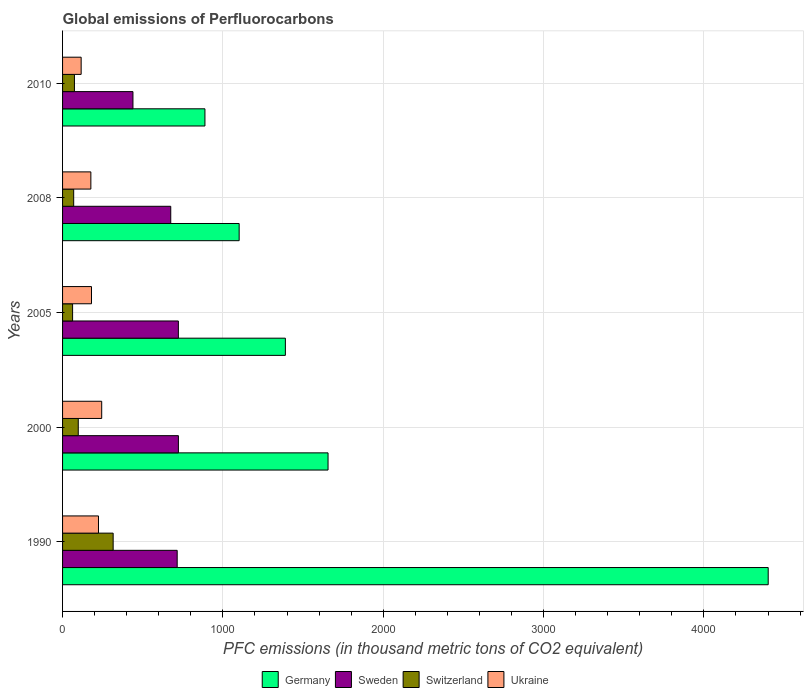How many different coloured bars are there?
Your response must be concise. 4. How many groups of bars are there?
Ensure brevity in your answer.  5. Are the number of bars per tick equal to the number of legend labels?
Your response must be concise. Yes. Are the number of bars on each tick of the Y-axis equal?
Give a very brief answer. Yes. How many bars are there on the 3rd tick from the bottom?
Your response must be concise. 4. What is the label of the 5th group of bars from the top?
Provide a short and direct response. 1990. In how many cases, is the number of bars for a given year not equal to the number of legend labels?
Give a very brief answer. 0. What is the global emissions of Perfluorocarbons in Switzerland in 2005?
Keep it short and to the point. 62.5. Across all years, what is the maximum global emissions of Perfluorocarbons in Germany?
Ensure brevity in your answer.  4401.3. Across all years, what is the minimum global emissions of Perfluorocarbons in Germany?
Make the answer very short. 888. In which year was the global emissions of Perfluorocarbons in Switzerland maximum?
Offer a terse response. 1990. What is the total global emissions of Perfluorocarbons in Ukraine in the graph?
Offer a terse response. 941.1. What is the difference between the global emissions of Perfluorocarbons in Ukraine in 1990 and that in 2008?
Your answer should be compact. 47.5. What is the difference between the global emissions of Perfluorocarbons in Germany in 2000 and the global emissions of Perfluorocarbons in Switzerland in 2008?
Give a very brief answer. 1586.5. What is the average global emissions of Perfluorocarbons in Switzerland per year?
Make the answer very short. 123.86. In the year 2005, what is the difference between the global emissions of Perfluorocarbons in Ukraine and global emissions of Perfluorocarbons in Germany?
Offer a terse response. -1209.2. In how many years, is the global emissions of Perfluorocarbons in Switzerland greater than 4400 thousand metric tons?
Offer a terse response. 0. What is the ratio of the global emissions of Perfluorocarbons in Sweden in 2000 to that in 2010?
Offer a very short reply. 1.65. Is the global emissions of Perfluorocarbons in Germany in 1990 less than that in 2008?
Provide a short and direct response. No. What is the difference between the highest and the second highest global emissions of Perfluorocarbons in Sweden?
Your answer should be very brief. 0.2. What is the difference between the highest and the lowest global emissions of Perfluorocarbons in Germany?
Offer a very short reply. 3513.3. In how many years, is the global emissions of Perfluorocarbons in Germany greater than the average global emissions of Perfluorocarbons in Germany taken over all years?
Your answer should be compact. 1. Is it the case that in every year, the sum of the global emissions of Perfluorocarbons in Switzerland and global emissions of Perfluorocarbons in Germany is greater than the sum of global emissions of Perfluorocarbons in Sweden and global emissions of Perfluorocarbons in Ukraine?
Give a very brief answer. No. What does the 3rd bar from the bottom in 2005 represents?
Your answer should be compact. Switzerland. Is it the case that in every year, the sum of the global emissions of Perfluorocarbons in Ukraine and global emissions of Perfluorocarbons in Switzerland is greater than the global emissions of Perfluorocarbons in Sweden?
Your response must be concise. No. Are the values on the major ticks of X-axis written in scientific E-notation?
Provide a succinct answer. No. Does the graph contain any zero values?
Provide a succinct answer. No. How many legend labels are there?
Your answer should be very brief. 4. How are the legend labels stacked?
Your response must be concise. Horizontal. What is the title of the graph?
Provide a short and direct response. Global emissions of Perfluorocarbons. Does "Albania" appear as one of the legend labels in the graph?
Your answer should be compact. No. What is the label or title of the X-axis?
Your response must be concise. PFC emissions (in thousand metric tons of CO2 equivalent). What is the PFC emissions (in thousand metric tons of CO2 equivalent) in Germany in 1990?
Make the answer very short. 4401.3. What is the PFC emissions (in thousand metric tons of CO2 equivalent) of Sweden in 1990?
Your answer should be very brief. 714.9. What is the PFC emissions (in thousand metric tons of CO2 equivalent) in Switzerland in 1990?
Offer a very short reply. 315.5. What is the PFC emissions (in thousand metric tons of CO2 equivalent) of Ukraine in 1990?
Your answer should be compact. 224. What is the PFC emissions (in thousand metric tons of CO2 equivalent) in Germany in 2000?
Ensure brevity in your answer.  1655.9. What is the PFC emissions (in thousand metric tons of CO2 equivalent) in Sweden in 2000?
Provide a succinct answer. 722.5. What is the PFC emissions (in thousand metric tons of CO2 equivalent) in Switzerland in 2000?
Make the answer very short. 97.9. What is the PFC emissions (in thousand metric tons of CO2 equivalent) of Ukraine in 2000?
Give a very brief answer. 244.1. What is the PFC emissions (in thousand metric tons of CO2 equivalent) in Germany in 2005?
Provide a succinct answer. 1389.7. What is the PFC emissions (in thousand metric tons of CO2 equivalent) in Sweden in 2005?
Your answer should be compact. 722.3. What is the PFC emissions (in thousand metric tons of CO2 equivalent) in Switzerland in 2005?
Ensure brevity in your answer.  62.5. What is the PFC emissions (in thousand metric tons of CO2 equivalent) of Ukraine in 2005?
Offer a very short reply. 180.5. What is the PFC emissions (in thousand metric tons of CO2 equivalent) in Germany in 2008?
Make the answer very short. 1101.4. What is the PFC emissions (in thousand metric tons of CO2 equivalent) of Sweden in 2008?
Make the answer very short. 674.8. What is the PFC emissions (in thousand metric tons of CO2 equivalent) of Switzerland in 2008?
Your answer should be compact. 69.4. What is the PFC emissions (in thousand metric tons of CO2 equivalent) in Ukraine in 2008?
Offer a very short reply. 176.5. What is the PFC emissions (in thousand metric tons of CO2 equivalent) of Germany in 2010?
Ensure brevity in your answer.  888. What is the PFC emissions (in thousand metric tons of CO2 equivalent) of Sweden in 2010?
Make the answer very short. 439. What is the PFC emissions (in thousand metric tons of CO2 equivalent) of Switzerland in 2010?
Give a very brief answer. 74. What is the PFC emissions (in thousand metric tons of CO2 equivalent) of Ukraine in 2010?
Your response must be concise. 116. Across all years, what is the maximum PFC emissions (in thousand metric tons of CO2 equivalent) in Germany?
Give a very brief answer. 4401.3. Across all years, what is the maximum PFC emissions (in thousand metric tons of CO2 equivalent) in Sweden?
Provide a short and direct response. 722.5. Across all years, what is the maximum PFC emissions (in thousand metric tons of CO2 equivalent) of Switzerland?
Keep it short and to the point. 315.5. Across all years, what is the maximum PFC emissions (in thousand metric tons of CO2 equivalent) in Ukraine?
Ensure brevity in your answer.  244.1. Across all years, what is the minimum PFC emissions (in thousand metric tons of CO2 equivalent) in Germany?
Give a very brief answer. 888. Across all years, what is the minimum PFC emissions (in thousand metric tons of CO2 equivalent) in Sweden?
Ensure brevity in your answer.  439. Across all years, what is the minimum PFC emissions (in thousand metric tons of CO2 equivalent) of Switzerland?
Your answer should be compact. 62.5. Across all years, what is the minimum PFC emissions (in thousand metric tons of CO2 equivalent) in Ukraine?
Your answer should be compact. 116. What is the total PFC emissions (in thousand metric tons of CO2 equivalent) in Germany in the graph?
Offer a very short reply. 9436.3. What is the total PFC emissions (in thousand metric tons of CO2 equivalent) in Sweden in the graph?
Your answer should be very brief. 3273.5. What is the total PFC emissions (in thousand metric tons of CO2 equivalent) in Switzerland in the graph?
Ensure brevity in your answer.  619.3. What is the total PFC emissions (in thousand metric tons of CO2 equivalent) in Ukraine in the graph?
Provide a succinct answer. 941.1. What is the difference between the PFC emissions (in thousand metric tons of CO2 equivalent) of Germany in 1990 and that in 2000?
Offer a terse response. 2745.4. What is the difference between the PFC emissions (in thousand metric tons of CO2 equivalent) of Switzerland in 1990 and that in 2000?
Keep it short and to the point. 217.6. What is the difference between the PFC emissions (in thousand metric tons of CO2 equivalent) of Ukraine in 1990 and that in 2000?
Offer a terse response. -20.1. What is the difference between the PFC emissions (in thousand metric tons of CO2 equivalent) in Germany in 1990 and that in 2005?
Provide a succinct answer. 3011.6. What is the difference between the PFC emissions (in thousand metric tons of CO2 equivalent) in Switzerland in 1990 and that in 2005?
Make the answer very short. 253. What is the difference between the PFC emissions (in thousand metric tons of CO2 equivalent) in Ukraine in 1990 and that in 2005?
Provide a succinct answer. 43.5. What is the difference between the PFC emissions (in thousand metric tons of CO2 equivalent) in Germany in 1990 and that in 2008?
Your answer should be compact. 3299.9. What is the difference between the PFC emissions (in thousand metric tons of CO2 equivalent) in Sweden in 1990 and that in 2008?
Provide a succinct answer. 40.1. What is the difference between the PFC emissions (in thousand metric tons of CO2 equivalent) of Switzerland in 1990 and that in 2008?
Provide a short and direct response. 246.1. What is the difference between the PFC emissions (in thousand metric tons of CO2 equivalent) of Ukraine in 1990 and that in 2008?
Your answer should be compact. 47.5. What is the difference between the PFC emissions (in thousand metric tons of CO2 equivalent) in Germany in 1990 and that in 2010?
Provide a short and direct response. 3513.3. What is the difference between the PFC emissions (in thousand metric tons of CO2 equivalent) in Sweden in 1990 and that in 2010?
Your answer should be compact. 275.9. What is the difference between the PFC emissions (in thousand metric tons of CO2 equivalent) in Switzerland in 1990 and that in 2010?
Give a very brief answer. 241.5. What is the difference between the PFC emissions (in thousand metric tons of CO2 equivalent) of Ukraine in 1990 and that in 2010?
Your answer should be compact. 108. What is the difference between the PFC emissions (in thousand metric tons of CO2 equivalent) of Germany in 2000 and that in 2005?
Keep it short and to the point. 266.2. What is the difference between the PFC emissions (in thousand metric tons of CO2 equivalent) in Switzerland in 2000 and that in 2005?
Your answer should be compact. 35.4. What is the difference between the PFC emissions (in thousand metric tons of CO2 equivalent) in Ukraine in 2000 and that in 2005?
Provide a succinct answer. 63.6. What is the difference between the PFC emissions (in thousand metric tons of CO2 equivalent) in Germany in 2000 and that in 2008?
Give a very brief answer. 554.5. What is the difference between the PFC emissions (in thousand metric tons of CO2 equivalent) of Sweden in 2000 and that in 2008?
Provide a short and direct response. 47.7. What is the difference between the PFC emissions (in thousand metric tons of CO2 equivalent) of Switzerland in 2000 and that in 2008?
Keep it short and to the point. 28.5. What is the difference between the PFC emissions (in thousand metric tons of CO2 equivalent) in Ukraine in 2000 and that in 2008?
Offer a terse response. 67.6. What is the difference between the PFC emissions (in thousand metric tons of CO2 equivalent) in Germany in 2000 and that in 2010?
Keep it short and to the point. 767.9. What is the difference between the PFC emissions (in thousand metric tons of CO2 equivalent) of Sweden in 2000 and that in 2010?
Offer a very short reply. 283.5. What is the difference between the PFC emissions (in thousand metric tons of CO2 equivalent) in Switzerland in 2000 and that in 2010?
Your answer should be compact. 23.9. What is the difference between the PFC emissions (in thousand metric tons of CO2 equivalent) of Ukraine in 2000 and that in 2010?
Your answer should be compact. 128.1. What is the difference between the PFC emissions (in thousand metric tons of CO2 equivalent) in Germany in 2005 and that in 2008?
Give a very brief answer. 288.3. What is the difference between the PFC emissions (in thousand metric tons of CO2 equivalent) of Sweden in 2005 and that in 2008?
Provide a succinct answer. 47.5. What is the difference between the PFC emissions (in thousand metric tons of CO2 equivalent) of Switzerland in 2005 and that in 2008?
Give a very brief answer. -6.9. What is the difference between the PFC emissions (in thousand metric tons of CO2 equivalent) of Ukraine in 2005 and that in 2008?
Offer a terse response. 4. What is the difference between the PFC emissions (in thousand metric tons of CO2 equivalent) in Germany in 2005 and that in 2010?
Ensure brevity in your answer.  501.7. What is the difference between the PFC emissions (in thousand metric tons of CO2 equivalent) of Sweden in 2005 and that in 2010?
Offer a terse response. 283.3. What is the difference between the PFC emissions (in thousand metric tons of CO2 equivalent) in Switzerland in 2005 and that in 2010?
Keep it short and to the point. -11.5. What is the difference between the PFC emissions (in thousand metric tons of CO2 equivalent) in Ukraine in 2005 and that in 2010?
Your response must be concise. 64.5. What is the difference between the PFC emissions (in thousand metric tons of CO2 equivalent) in Germany in 2008 and that in 2010?
Make the answer very short. 213.4. What is the difference between the PFC emissions (in thousand metric tons of CO2 equivalent) in Sweden in 2008 and that in 2010?
Offer a very short reply. 235.8. What is the difference between the PFC emissions (in thousand metric tons of CO2 equivalent) in Switzerland in 2008 and that in 2010?
Your answer should be compact. -4.6. What is the difference between the PFC emissions (in thousand metric tons of CO2 equivalent) in Ukraine in 2008 and that in 2010?
Offer a very short reply. 60.5. What is the difference between the PFC emissions (in thousand metric tons of CO2 equivalent) of Germany in 1990 and the PFC emissions (in thousand metric tons of CO2 equivalent) of Sweden in 2000?
Offer a terse response. 3678.8. What is the difference between the PFC emissions (in thousand metric tons of CO2 equivalent) in Germany in 1990 and the PFC emissions (in thousand metric tons of CO2 equivalent) in Switzerland in 2000?
Give a very brief answer. 4303.4. What is the difference between the PFC emissions (in thousand metric tons of CO2 equivalent) of Germany in 1990 and the PFC emissions (in thousand metric tons of CO2 equivalent) of Ukraine in 2000?
Your response must be concise. 4157.2. What is the difference between the PFC emissions (in thousand metric tons of CO2 equivalent) in Sweden in 1990 and the PFC emissions (in thousand metric tons of CO2 equivalent) in Switzerland in 2000?
Provide a succinct answer. 617. What is the difference between the PFC emissions (in thousand metric tons of CO2 equivalent) of Sweden in 1990 and the PFC emissions (in thousand metric tons of CO2 equivalent) of Ukraine in 2000?
Keep it short and to the point. 470.8. What is the difference between the PFC emissions (in thousand metric tons of CO2 equivalent) of Switzerland in 1990 and the PFC emissions (in thousand metric tons of CO2 equivalent) of Ukraine in 2000?
Your answer should be compact. 71.4. What is the difference between the PFC emissions (in thousand metric tons of CO2 equivalent) in Germany in 1990 and the PFC emissions (in thousand metric tons of CO2 equivalent) in Sweden in 2005?
Provide a succinct answer. 3679. What is the difference between the PFC emissions (in thousand metric tons of CO2 equivalent) of Germany in 1990 and the PFC emissions (in thousand metric tons of CO2 equivalent) of Switzerland in 2005?
Provide a short and direct response. 4338.8. What is the difference between the PFC emissions (in thousand metric tons of CO2 equivalent) in Germany in 1990 and the PFC emissions (in thousand metric tons of CO2 equivalent) in Ukraine in 2005?
Make the answer very short. 4220.8. What is the difference between the PFC emissions (in thousand metric tons of CO2 equivalent) in Sweden in 1990 and the PFC emissions (in thousand metric tons of CO2 equivalent) in Switzerland in 2005?
Your response must be concise. 652.4. What is the difference between the PFC emissions (in thousand metric tons of CO2 equivalent) of Sweden in 1990 and the PFC emissions (in thousand metric tons of CO2 equivalent) of Ukraine in 2005?
Your response must be concise. 534.4. What is the difference between the PFC emissions (in thousand metric tons of CO2 equivalent) of Switzerland in 1990 and the PFC emissions (in thousand metric tons of CO2 equivalent) of Ukraine in 2005?
Make the answer very short. 135. What is the difference between the PFC emissions (in thousand metric tons of CO2 equivalent) of Germany in 1990 and the PFC emissions (in thousand metric tons of CO2 equivalent) of Sweden in 2008?
Keep it short and to the point. 3726.5. What is the difference between the PFC emissions (in thousand metric tons of CO2 equivalent) in Germany in 1990 and the PFC emissions (in thousand metric tons of CO2 equivalent) in Switzerland in 2008?
Your answer should be very brief. 4331.9. What is the difference between the PFC emissions (in thousand metric tons of CO2 equivalent) of Germany in 1990 and the PFC emissions (in thousand metric tons of CO2 equivalent) of Ukraine in 2008?
Your answer should be very brief. 4224.8. What is the difference between the PFC emissions (in thousand metric tons of CO2 equivalent) of Sweden in 1990 and the PFC emissions (in thousand metric tons of CO2 equivalent) of Switzerland in 2008?
Provide a short and direct response. 645.5. What is the difference between the PFC emissions (in thousand metric tons of CO2 equivalent) in Sweden in 1990 and the PFC emissions (in thousand metric tons of CO2 equivalent) in Ukraine in 2008?
Make the answer very short. 538.4. What is the difference between the PFC emissions (in thousand metric tons of CO2 equivalent) of Switzerland in 1990 and the PFC emissions (in thousand metric tons of CO2 equivalent) of Ukraine in 2008?
Provide a short and direct response. 139. What is the difference between the PFC emissions (in thousand metric tons of CO2 equivalent) of Germany in 1990 and the PFC emissions (in thousand metric tons of CO2 equivalent) of Sweden in 2010?
Provide a short and direct response. 3962.3. What is the difference between the PFC emissions (in thousand metric tons of CO2 equivalent) in Germany in 1990 and the PFC emissions (in thousand metric tons of CO2 equivalent) in Switzerland in 2010?
Ensure brevity in your answer.  4327.3. What is the difference between the PFC emissions (in thousand metric tons of CO2 equivalent) of Germany in 1990 and the PFC emissions (in thousand metric tons of CO2 equivalent) of Ukraine in 2010?
Provide a succinct answer. 4285.3. What is the difference between the PFC emissions (in thousand metric tons of CO2 equivalent) in Sweden in 1990 and the PFC emissions (in thousand metric tons of CO2 equivalent) in Switzerland in 2010?
Make the answer very short. 640.9. What is the difference between the PFC emissions (in thousand metric tons of CO2 equivalent) of Sweden in 1990 and the PFC emissions (in thousand metric tons of CO2 equivalent) of Ukraine in 2010?
Provide a short and direct response. 598.9. What is the difference between the PFC emissions (in thousand metric tons of CO2 equivalent) in Switzerland in 1990 and the PFC emissions (in thousand metric tons of CO2 equivalent) in Ukraine in 2010?
Make the answer very short. 199.5. What is the difference between the PFC emissions (in thousand metric tons of CO2 equivalent) in Germany in 2000 and the PFC emissions (in thousand metric tons of CO2 equivalent) in Sweden in 2005?
Your answer should be very brief. 933.6. What is the difference between the PFC emissions (in thousand metric tons of CO2 equivalent) in Germany in 2000 and the PFC emissions (in thousand metric tons of CO2 equivalent) in Switzerland in 2005?
Your answer should be very brief. 1593.4. What is the difference between the PFC emissions (in thousand metric tons of CO2 equivalent) of Germany in 2000 and the PFC emissions (in thousand metric tons of CO2 equivalent) of Ukraine in 2005?
Give a very brief answer. 1475.4. What is the difference between the PFC emissions (in thousand metric tons of CO2 equivalent) of Sweden in 2000 and the PFC emissions (in thousand metric tons of CO2 equivalent) of Switzerland in 2005?
Your answer should be very brief. 660. What is the difference between the PFC emissions (in thousand metric tons of CO2 equivalent) of Sweden in 2000 and the PFC emissions (in thousand metric tons of CO2 equivalent) of Ukraine in 2005?
Provide a short and direct response. 542. What is the difference between the PFC emissions (in thousand metric tons of CO2 equivalent) of Switzerland in 2000 and the PFC emissions (in thousand metric tons of CO2 equivalent) of Ukraine in 2005?
Provide a succinct answer. -82.6. What is the difference between the PFC emissions (in thousand metric tons of CO2 equivalent) of Germany in 2000 and the PFC emissions (in thousand metric tons of CO2 equivalent) of Sweden in 2008?
Make the answer very short. 981.1. What is the difference between the PFC emissions (in thousand metric tons of CO2 equivalent) in Germany in 2000 and the PFC emissions (in thousand metric tons of CO2 equivalent) in Switzerland in 2008?
Offer a terse response. 1586.5. What is the difference between the PFC emissions (in thousand metric tons of CO2 equivalent) in Germany in 2000 and the PFC emissions (in thousand metric tons of CO2 equivalent) in Ukraine in 2008?
Ensure brevity in your answer.  1479.4. What is the difference between the PFC emissions (in thousand metric tons of CO2 equivalent) in Sweden in 2000 and the PFC emissions (in thousand metric tons of CO2 equivalent) in Switzerland in 2008?
Provide a short and direct response. 653.1. What is the difference between the PFC emissions (in thousand metric tons of CO2 equivalent) in Sweden in 2000 and the PFC emissions (in thousand metric tons of CO2 equivalent) in Ukraine in 2008?
Your answer should be very brief. 546. What is the difference between the PFC emissions (in thousand metric tons of CO2 equivalent) of Switzerland in 2000 and the PFC emissions (in thousand metric tons of CO2 equivalent) of Ukraine in 2008?
Keep it short and to the point. -78.6. What is the difference between the PFC emissions (in thousand metric tons of CO2 equivalent) of Germany in 2000 and the PFC emissions (in thousand metric tons of CO2 equivalent) of Sweden in 2010?
Offer a terse response. 1216.9. What is the difference between the PFC emissions (in thousand metric tons of CO2 equivalent) of Germany in 2000 and the PFC emissions (in thousand metric tons of CO2 equivalent) of Switzerland in 2010?
Your answer should be compact. 1581.9. What is the difference between the PFC emissions (in thousand metric tons of CO2 equivalent) of Germany in 2000 and the PFC emissions (in thousand metric tons of CO2 equivalent) of Ukraine in 2010?
Your response must be concise. 1539.9. What is the difference between the PFC emissions (in thousand metric tons of CO2 equivalent) of Sweden in 2000 and the PFC emissions (in thousand metric tons of CO2 equivalent) of Switzerland in 2010?
Offer a terse response. 648.5. What is the difference between the PFC emissions (in thousand metric tons of CO2 equivalent) in Sweden in 2000 and the PFC emissions (in thousand metric tons of CO2 equivalent) in Ukraine in 2010?
Offer a terse response. 606.5. What is the difference between the PFC emissions (in thousand metric tons of CO2 equivalent) in Switzerland in 2000 and the PFC emissions (in thousand metric tons of CO2 equivalent) in Ukraine in 2010?
Offer a terse response. -18.1. What is the difference between the PFC emissions (in thousand metric tons of CO2 equivalent) of Germany in 2005 and the PFC emissions (in thousand metric tons of CO2 equivalent) of Sweden in 2008?
Your response must be concise. 714.9. What is the difference between the PFC emissions (in thousand metric tons of CO2 equivalent) in Germany in 2005 and the PFC emissions (in thousand metric tons of CO2 equivalent) in Switzerland in 2008?
Offer a terse response. 1320.3. What is the difference between the PFC emissions (in thousand metric tons of CO2 equivalent) of Germany in 2005 and the PFC emissions (in thousand metric tons of CO2 equivalent) of Ukraine in 2008?
Your answer should be very brief. 1213.2. What is the difference between the PFC emissions (in thousand metric tons of CO2 equivalent) in Sweden in 2005 and the PFC emissions (in thousand metric tons of CO2 equivalent) in Switzerland in 2008?
Offer a very short reply. 652.9. What is the difference between the PFC emissions (in thousand metric tons of CO2 equivalent) of Sweden in 2005 and the PFC emissions (in thousand metric tons of CO2 equivalent) of Ukraine in 2008?
Provide a succinct answer. 545.8. What is the difference between the PFC emissions (in thousand metric tons of CO2 equivalent) of Switzerland in 2005 and the PFC emissions (in thousand metric tons of CO2 equivalent) of Ukraine in 2008?
Make the answer very short. -114. What is the difference between the PFC emissions (in thousand metric tons of CO2 equivalent) in Germany in 2005 and the PFC emissions (in thousand metric tons of CO2 equivalent) in Sweden in 2010?
Offer a very short reply. 950.7. What is the difference between the PFC emissions (in thousand metric tons of CO2 equivalent) of Germany in 2005 and the PFC emissions (in thousand metric tons of CO2 equivalent) of Switzerland in 2010?
Offer a terse response. 1315.7. What is the difference between the PFC emissions (in thousand metric tons of CO2 equivalent) in Germany in 2005 and the PFC emissions (in thousand metric tons of CO2 equivalent) in Ukraine in 2010?
Provide a short and direct response. 1273.7. What is the difference between the PFC emissions (in thousand metric tons of CO2 equivalent) in Sweden in 2005 and the PFC emissions (in thousand metric tons of CO2 equivalent) in Switzerland in 2010?
Offer a very short reply. 648.3. What is the difference between the PFC emissions (in thousand metric tons of CO2 equivalent) in Sweden in 2005 and the PFC emissions (in thousand metric tons of CO2 equivalent) in Ukraine in 2010?
Provide a short and direct response. 606.3. What is the difference between the PFC emissions (in thousand metric tons of CO2 equivalent) in Switzerland in 2005 and the PFC emissions (in thousand metric tons of CO2 equivalent) in Ukraine in 2010?
Offer a terse response. -53.5. What is the difference between the PFC emissions (in thousand metric tons of CO2 equivalent) in Germany in 2008 and the PFC emissions (in thousand metric tons of CO2 equivalent) in Sweden in 2010?
Offer a very short reply. 662.4. What is the difference between the PFC emissions (in thousand metric tons of CO2 equivalent) of Germany in 2008 and the PFC emissions (in thousand metric tons of CO2 equivalent) of Switzerland in 2010?
Keep it short and to the point. 1027.4. What is the difference between the PFC emissions (in thousand metric tons of CO2 equivalent) of Germany in 2008 and the PFC emissions (in thousand metric tons of CO2 equivalent) of Ukraine in 2010?
Offer a very short reply. 985.4. What is the difference between the PFC emissions (in thousand metric tons of CO2 equivalent) of Sweden in 2008 and the PFC emissions (in thousand metric tons of CO2 equivalent) of Switzerland in 2010?
Keep it short and to the point. 600.8. What is the difference between the PFC emissions (in thousand metric tons of CO2 equivalent) in Sweden in 2008 and the PFC emissions (in thousand metric tons of CO2 equivalent) in Ukraine in 2010?
Offer a terse response. 558.8. What is the difference between the PFC emissions (in thousand metric tons of CO2 equivalent) in Switzerland in 2008 and the PFC emissions (in thousand metric tons of CO2 equivalent) in Ukraine in 2010?
Your response must be concise. -46.6. What is the average PFC emissions (in thousand metric tons of CO2 equivalent) in Germany per year?
Make the answer very short. 1887.26. What is the average PFC emissions (in thousand metric tons of CO2 equivalent) of Sweden per year?
Provide a succinct answer. 654.7. What is the average PFC emissions (in thousand metric tons of CO2 equivalent) of Switzerland per year?
Provide a short and direct response. 123.86. What is the average PFC emissions (in thousand metric tons of CO2 equivalent) in Ukraine per year?
Your answer should be compact. 188.22. In the year 1990, what is the difference between the PFC emissions (in thousand metric tons of CO2 equivalent) in Germany and PFC emissions (in thousand metric tons of CO2 equivalent) in Sweden?
Your response must be concise. 3686.4. In the year 1990, what is the difference between the PFC emissions (in thousand metric tons of CO2 equivalent) in Germany and PFC emissions (in thousand metric tons of CO2 equivalent) in Switzerland?
Give a very brief answer. 4085.8. In the year 1990, what is the difference between the PFC emissions (in thousand metric tons of CO2 equivalent) in Germany and PFC emissions (in thousand metric tons of CO2 equivalent) in Ukraine?
Provide a short and direct response. 4177.3. In the year 1990, what is the difference between the PFC emissions (in thousand metric tons of CO2 equivalent) of Sweden and PFC emissions (in thousand metric tons of CO2 equivalent) of Switzerland?
Provide a succinct answer. 399.4. In the year 1990, what is the difference between the PFC emissions (in thousand metric tons of CO2 equivalent) of Sweden and PFC emissions (in thousand metric tons of CO2 equivalent) of Ukraine?
Your answer should be very brief. 490.9. In the year 1990, what is the difference between the PFC emissions (in thousand metric tons of CO2 equivalent) in Switzerland and PFC emissions (in thousand metric tons of CO2 equivalent) in Ukraine?
Keep it short and to the point. 91.5. In the year 2000, what is the difference between the PFC emissions (in thousand metric tons of CO2 equivalent) of Germany and PFC emissions (in thousand metric tons of CO2 equivalent) of Sweden?
Your response must be concise. 933.4. In the year 2000, what is the difference between the PFC emissions (in thousand metric tons of CO2 equivalent) of Germany and PFC emissions (in thousand metric tons of CO2 equivalent) of Switzerland?
Keep it short and to the point. 1558. In the year 2000, what is the difference between the PFC emissions (in thousand metric tons of CO2 equivalent) of Germany and PFC emissions (in thousand metric tons of CO2 equivalent) of Ukraine?
Your response must be concise. 1411.8. In the year 2000, what is the difference between the PFC emissions (in thousand metric tons of CO2 equivalent) of Sweden and PFC emissions (in thousand metric tons of CO2 equivalent) of Switzerland?
Keep it short and to the point. 624.6. In the year 2000, what is the difference between the PFC emissions (in thousand metric tons of CO2 equivalent) in Sweden and PFC emissions (in thousand metric tons of CO2 equivalent) in Ukraine?
Offer a terse response. 478.4. In the year 2000, what is the difference between the PFC emissions (in thousand metric tons of CO2 equivalent) of Switzerland and PFC emissions (in thousand metric tons of CO2 equivalent) of Ukraine?
Your response must be concise. -146.2. In the year 2005, what is the difference between the PFC emissions (in thousand metric tons of CO2 equivalent) in Germany and PFC emissions (in thousand metric tons of CO2 equivalent) in Sweden?
Provide a succinct answer. 667.4. In the year 2005, what is the difference between the PFC emissions (in thousand metric tons of CO2 equivalent) of Germany and PFC emissions (in thousand metric tons of CO2 equivalent) of Switzerland?
Your answer should be very brief. 1327.2. In the year 2005, what is the difference between the PFC emissions (in thousand metric tons of CO2 equivalent) in Germany and PFC emissions (in thousand metric tons of CO2 equivalent) in Ukraine?
Ensure brevity in your answer.  1209.2. In the year 2005, what is the difference between the PFC emissions (in thousand metric tons of CO2 equivalent) of Sweden and PFC emissions (in thousand metric tons of CO2 equivalent) of Switzerland?
Your answer should be very brief. 659.8. In the year 2005, what is the difference between the PFC emissions (in thousand metric tons of CO2 equivalent) in Sweden and PFC emissions (in thousand metric tons of CO2 equivalent) in Ukraine?
Offer a terse response. 541.8. In the year 2005, what is the difference between the PFC emissions (in thousand metric tons of CO2 equivalent) of Switzerland and PFC emissions (in thousand metric tons of CO2 equivalent) of Ukraine?
Your answer should be very brief. -118. In the year 2008, what is the difference between the PFC emissions (in thousand metric tons of CO2 equivalent) in Germany and PFC emissions (in thousand metric tons of CO2 equivalent) in Sweden?
Your response must be concise. 426.6. In the year 2008, what is the difference between the PFC emissions (in thousand metric tons of CO2 equivalent) of Germany and PFC emissions (in thousand metric tons of CO2 equivalent) of Switzerland?
Provide a short and direct response. 1032. In the year 2008, what is the difference between the PFC emissions (in thousand metric tons of CO2 equivalent) of Germany and PFC emissions (in thousand metric tons of CO2 equivalent) of Ukraine?
Provide a succinct answer. 924.9. In the year 2008, what is the difference between the PFC emissions (in thousand metric tons of CO2 equivalent) of Sweden and PFC emissions (in thousand metric tons of CO2 equivalent) of Switzerland?
Provide a succinct answer. 605.4. In the year 2008, what is the difference between the PFC emissions (in thousand metric tons of CO2 equivalent) of Sweden and PFC emissions (in thousand metric tons of CO2 equivalent) of Ukraine?
Your response must be concise. 498.3. In the year 2008, what is the difference between the PFC emissions (in thousand metric tons of CO2 equivalent) in Switzerland and PFC emissions (in thousand metric tons of CO2 equivalent) in Ukraine?
Your answer should be compact. -107.1. In the year 2010, what is the difference between the PFC emissions (in thousand metric tons of CO2 equivalent) in Germany and PFC emissions (in thousand metric tons of CO2 equivalent) in Sweden?
Make the answer very short. 449. In the year 2010, what is the difference between the PFC emissions (in thousand metric tons of CO2 equivalent) of Germany and PFC emissions (in thousand metric tons of CO2 equivalent) of Switzerland?
Provide a succinct answer. 814. In the year 2010, what is the difference between the PFC emissions (in thousand metric tons of CO2 equivalent) in Germany and PFC emissions (in thousand metric tons of CO2 equivalent) in Ukraine?
Your response must be concise. 772. In the year 2010, what is the difference between the PFC emissions (in thousand metric tons of CO2 equivalent) in Sweden and PFC emissions (in thousand metric tons of CO2 equivalent) in Switzerland?
Make the answer very short. 365. In the year 2010, what is the difference between the PFC emissions (in thousand metric tons of CO2 equivalent) of Sweden and PFC emissions (in thousand metric tons of CO2 equivalent) of Ukraine?
Provide a succinct answer. 323. In the year 2010, what is the difference between the PFC emissions (in thousand metric tons of CO2 equivalent) of Switzerland and PFC emissions (in thousand metric tons of CO2 equivalent) of Ukraine?
Your answer should be very brief. -42. What is the ratio of the PFC emissions (in thousand metric tons of CO2 equivalent) of Germany in 1990 to that in 2000?
Your response must be concise. 2.66. What is the ratio of the PFC emissions (in thousand metric tons of CO2 equivalent) of Switzerland in 1990 to that in 2000?
Provide a short and direct response. 3.22. What is the ratio of the PFC emissions (in thousand metric tons of CO2 equivalent) of Ukraine in 1990 to that in 2000?
Give a very brief answer. 0.92. What is the ratio of the PFC emissions (in thousand metric tons of CO2 equivalent) of Germany in 1990 to that in 2005?
Ensure brevity in your answer.  3.17. What is the ratio of the PFC emissions (in thousand metric tons of CO2 equivalent) of Switzerland in 1990 to that in 2005?
Offer a very short reply. 5.05. What is the ratio of the PFC emissions (in thousand metric tons of CO2 equivalent) in Ukraine in 1990 to that in 2005?
Provide a short and direct response. 1.24. What is the ratio of the PFC emissions (in thousand metric tons of CO2 equivalent) of Germany in 1990 to that in 2008?
Your response must be concise. 4. What is the ratio of the PFC emissions (in thousand metric tons of CO2 equivalent) of Sweden in 1990 to that in 2008?
Make the answer very short. 1.06. What is the ratio of the PFC emissions (in thousand metric tons of CO2 equivalent) in Switzerland in 1990 to that in 2008?
Ensure brevity in your answer.  4.55. What is the ratio of the PFC emissions (in thousand metric tons of CO2 equivalent) in Ukraine in 1990 to that in 2008?
Your answer should be compact. 1.27. What is the ratio of the PFC emissions (in thousand metric tons of CO2 equivalent) in Germany in 1990 to that in 2010?
Offer a terse response. 4.96. What is the ratio of the PFC emissions (in thousand metric tons of CO2 equivalent) of Sweden in 1990 to that in 2010?
Provide a succinct answer. 1.63. What is the ratio of the PFC emissions (in thousand metric tons of CO2 equivalent) in Switzerland in 1990 to that in 2010?
Give a very brief answer. 4.26. What is the ratio of the PFC emissions (in thousand metric tons of CO2 equivalent) in Ukraine in 1990 to that in 2010?
Ensure brevity in your answer.  1.93. What is the ratio of the PFC emissions (in thousand metric tons of CO2 equivalent) in Germany in 2000 to that in 2005?
Ensure brevity in your answer.  1.19. What is the ratio of the PFC emissions (in thousand metric tons of CO2 equivalent) of Sweden in 2000 to that in 2005?
Give a very brief answer. 1. What is the ratio of the PFC emissions (in thousand metric tons of CO2 equivalent) of Switzerland in 2000 to that in 2005?
Offer a terse response. 1.57. What is the ratio of the PFC emissions (in thousand metric tons of CO2 equivalent) of Ukraine in 2000 to that in 2005?
Offer a terse response. 1.35. What is the ratio of the PFC emissions (in thousand metric tons of CO2 equivalent) in Germany in 2000 to that in 2008?
Offer a very short reply. 1.5. What is the ratio of the PFC emissions (in thousand metric tons of CO2 equivalent) of Sweden in 2000 to that in 2008?
Make the answer very short. 1.07. What is the ratio of the PFC emissions (in thousand metric tons of CO2 equivalent) in Switzerland in 2000 to that in 2008?
Ensure brevity in your answer.  1.41. What is the ratio of the PFC emissions (in thousand metric tons of CO2 equivalent) in Ukraine in 2000 to that in 2008?
Keep it short and to the point. 1.38. What is the ratio of the PFC emissions (in thousand metric tons of CO2 equivalent) in Germany in 2000 to that in 2010?
Provide a short and direct response. 1.86. What is the ratio of the PFC emissions (in thousand metric tons of CO2 equivalent) of Sweden in 2000 to that in 2010?
Offer a terse response. 1.65. What is the ratio of the PFC emissions (in thousand metric tons of CO2 equivalent) of Switzerland in 2000 to that in 2010?
Your answer should be very brief. 1.32. What is the ratio of the PFC emissions (in thousand metric tons of CO2 equivalent) of Ukraine in 2000 to that in 2010?
Ensure brevity in your answer.  2.1. What is the ratio of the PFC emissions (in thousand metric tons of CO2 equivalent) of Germany in 2005 to that in 2008?
Keep it short and to the point. 1.26. What is the ratio of the PFC emissions (in thousand metric tons of CO2 equivalent) in Sweden in 2005 to that in 2008?
Make the answer very short. 1.07. What is the ratio of the PFC emissions (in thousand metric tons of CO2 equivalent) of Switzerland in 2005 to that in 2008?
Provide a succinct answer. 0.9. What is the ratio of the PFC emissions (in thousand metric tons of CO2 equivalent) in Ukraine in 2005 to that in 2008?
Ensure brevity in your answer.  1.02. What is the ratio of the PFC emissions (in thousand metric tons of CO2 equivalent) of Germany in 2005 to that in 2010?
Your answer should be very brief. 1.56. What is the ratio of the PFC emissions (in thousand metric tons of CO2 equivalent) in Sweden in 2005 to that in 2010?
Provide a succinct answer. 1.65. What is the ratio of the PFC emissions (in thousand metric tons of CO2 equivalent) of Switzerland in 2005 to that in 2010?
Provide a short and direct response. 0.84. What is the ratio of the PFC emissions (in thousand metric tons of CO2 equivalent) in Ukraine in 2005 to that in 2010?
Give a very brief answer. 1.56. What is the ratio of the PFC emissions (in thousand metric tons of CO2 equivalent) of Germany in 2008 to that in 2010?
Your response must be concise. 1.24. What is the ratio of the PFC emissions (in thousand metric tons of CO2 equivalent) in Sweden in 2008 to that in 2010?
Offer a very short reply. 1.54. What is the ratio of the PFC emissions (in thousand metric tons of CO2 equivalent) in Switzerland in 2008 to that in 2010?
Ensure brevity in your answer.  0.94. What is the ratio of the PFC emissions (in thousand metric tons of CO2 equivalent) in Ukraine in 2008 to that in 2010?
Offer a very short reply. 1.52. What is the difference between the highest and the second highest PFC emissions (in thousand metric tons of CO2 equivalent) of Germany?
Offer a terse response. 2745.4. What is the difference between the highest and the second highest PFC emissions (in thousand metric tons of CO2 equivalent) of Switzerland?
Keep it short and to the point. 217.6. What is the difference between the highest and the second highest PFC emissions (in thousand metric tons of CO2 equivalent) of Ukraine?
Your answer should be very brief. 20.1. What is the difference between the highest and the lowest PFC emissions (in thousand metric tons of CO2 equivalent) in Germany?
Ensure brevity in your answer.  3513.3. What is the difference between the highest and the lowest PFC emissions (in thousand metric tons of CO2 equivalent) of Sweden?
Provide a succinct answer. 283.5. What is the difference between the highest and the lowest PFC emissions (in thousand metric tons of CO2 equivalent) in Switzerland?
Ensure brevity in your answer.  253. What is the difference between the highest and the lowest PFC emissions (in thousand metric tons of CO2 equivalent) of Ukraine?
Give a very brief answer. 128.1. 